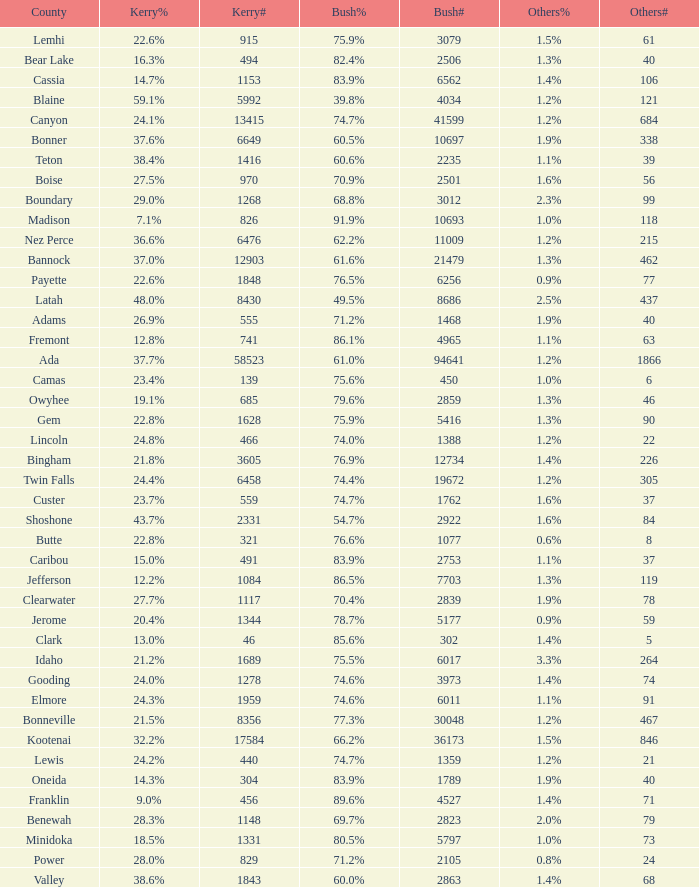What's percentage voted for Busg in the county where Kerry got 37.6%? 60.5%. 